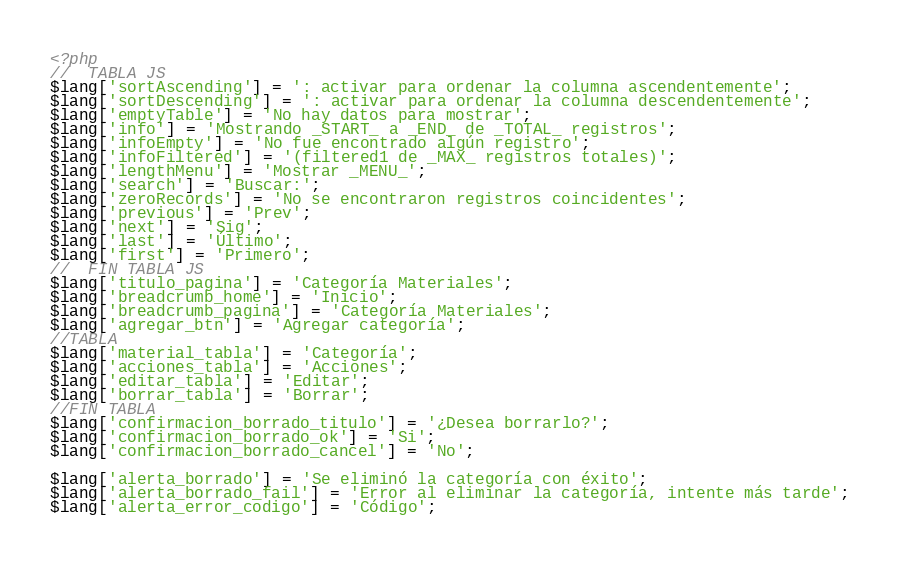Convert code to text. <code><loc_0><loc_0><loc_500><loc_500><_PHP_><?php
//  TABLA JS
$lang['sortAscending'] = ': activar para ordenar la columna ascendentemente';
$lang['sortDescending'] = ': activar para ordenar la columna descendentemente';
$lang['emptyTable'] = 'No hay datos para mostrar';
$lang['info'] = 'Mostrando _START_ a _END_ de _TOTAL_ registros';
$lang['infoEmpty'] = 'No fue encontrado algún registro';
$lang['infoFiltered'] = '(filtered1 de _MAX_ registros totales)';
$lang['lengthMenu'] = 'Mostrar _MENU_';
$lang['search'] = 'Buscar:';
$lang['zeroRecords'] = 'No se encontraron registros coincidentes';
$lang['previous'] = 'Prev';
$lang['next'] = 'Sig';
$lang['last'] = 'Último';
$lang['first'] = 'Primero';
//  FIN TABLA JS
$lang['titulo_pagina'] = 'Categoría Materiales';
$lang['breadcrumb_home'] = 'Inicio';
$lang['breadcrumb_pagina'] = 'Categoría Materiales';
$lang['agregar_btn'] = 'Agregar categoría';
//TABLA
$lang['material_tabla'] = 'Categoría';
$lang['acciones_tabla'] = 'Acciones';
$lang['editar_tabla'] = 'Editar';
$lang['borrar_tabla'] = 'Borrar';
//FIN TABLA
$lang['confirmacion_borrado_titulo'] = '¿Desea borrarlo?';
$lang['confirmacion_borrado_ok'] = 'Si';
$lang['confirmacion_borrado_cancel'] = 'No';

$lang['alerta_borrado'] = 'Se eliminó la categoría con éxito';
$lang['alerta_borrado_fail'] = 'Error al eliminar la categoría, intente más tarde';
$lang['alerta_error_codigo'] = 'Código';</code> 